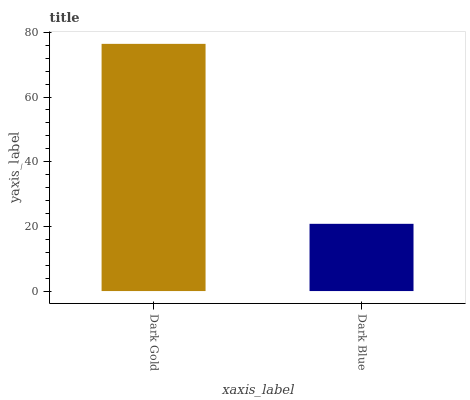Is Dark Blue the maximum?
Answer yes or no. No. Is Dark Gold greater than Dark Blue?
Answer yes or no. Yes. Is Dark Blue less than Dark Gold?
Answer yes or no. Yes. Is Dark Blue greater than Dark Gold?
Answer yes or no. No. Is Dark Gold less than Dark Blue?
Answer yes or no. No. Is Dark Gold the high median?
Answer yes or no. Yes. Is Dark Blue the low median?
Answer yes or no. Yes. Is Dark Blue the high median?
Answer yes or no. No. Is Dark Gold the low median?
Answer yes or no. No. 